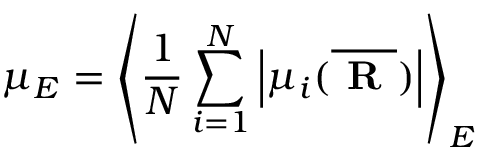<formula> <loc_0><loc_0><loc_500><loc_500>\mu _ { E } = \left < \frac { 1 } { N } \sum _ { i = 1 } ^ { N } \left | \mu _ { i } ( \overline { R } ) \right | \right > _ { E }</formula> 